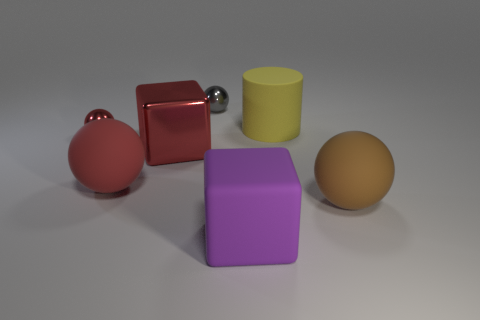Is the number of large red metal blocks behind the small red thing less than the number of purple things that are behind the big purple block? After closely examining the image, it appears that there is only one large red block visible, which is indeed positioned behind the small red ball. However, the purple objects consist of one large purple block and one smaller object akin to a sphere, with the former being at the forefront rather than behind. Therefore, because there are two red items compared to one purple object in the relevant positions, it would be incorrect to say that the number of large red metal blocks behind the small red thing is less than the number of purple things behind the big purple block. In fact, there appears to be no purple object positioned behind the large purple block at all. 